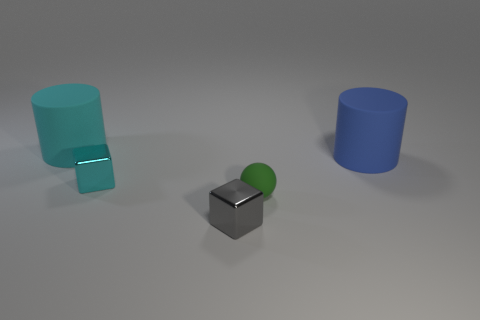Add 4 cyan cubes. How many objects exist? 9 Subtract all cubes. How many objects are left? 3 Subtract 0 gray cylinders. How many objects are left? 5 Subtract all tiny gray things. Subtract all tiny blue cylinders. How many objects are left? 4 Add 3 small gray shiny objects. How many small gray shiny objects are left? 4 Add 1 yellow rubber blocks. How many yellow rubber blocks exist? 1 